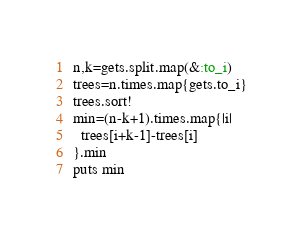Convert code to text. <code><loc_0><loc_0><loc_500><loc_500><_Ruby_>n,k=gets.split.map(&:to_i)
trees=n.times.map{gets.to_i}
trees.sort!
min=(n-k+1).times.map{|i|
  trees[i+k-1]-trees[i]
}.min
puts min</code> 